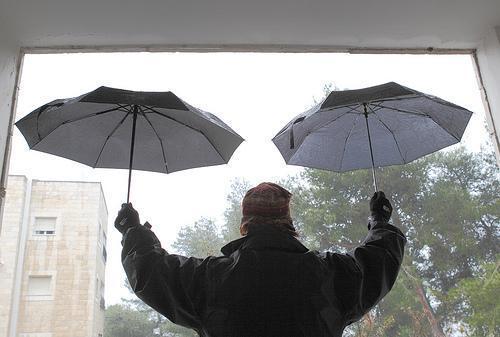How many umbrellas?
Give a very brief answer. 2. 